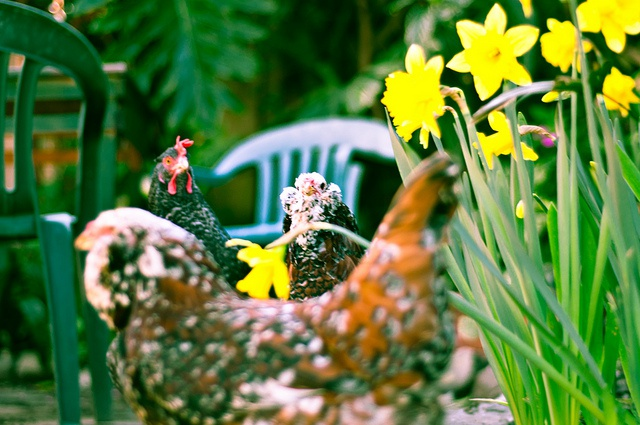Describe the objects in this image and their specific colors. I can see bird in teal, olive, darkgreen, and lavender tones, chair in teal, darkgreen, and olive tones, chair in teal, lavender, and lightblue tones, bird in teal, black, lavender, olive, and darkgreen tones, and bird in teal and darkgreen tones in this image. 